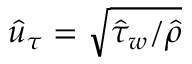Convert formula to latex. <formula><loc_0><loc_0><loc_500><loc_500>\hat { u } _ { \tau } = \sqrt { \hat { \tau } _ { w } / \hat { \rho } }</formula> 